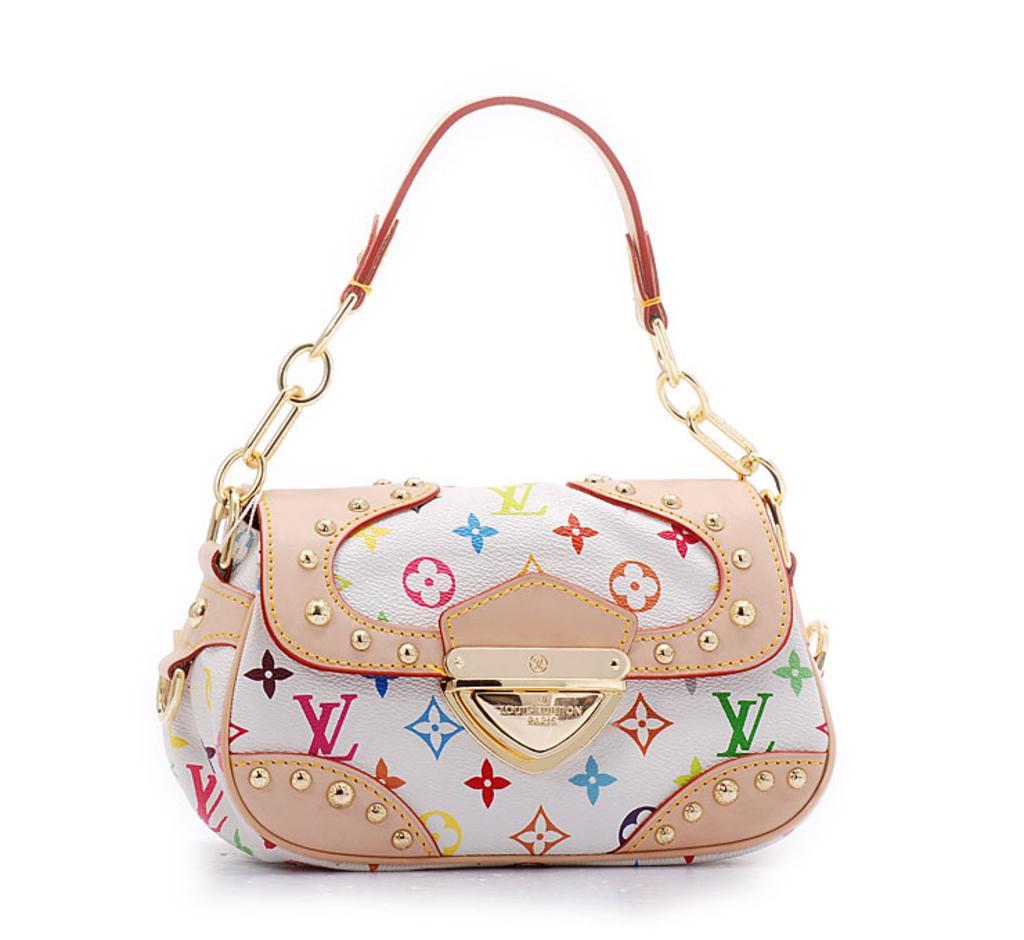How would you summarize this image in a sentence or two? A bag is highlighted in this picture. It as a chain. This bag color is in white and peach color. 